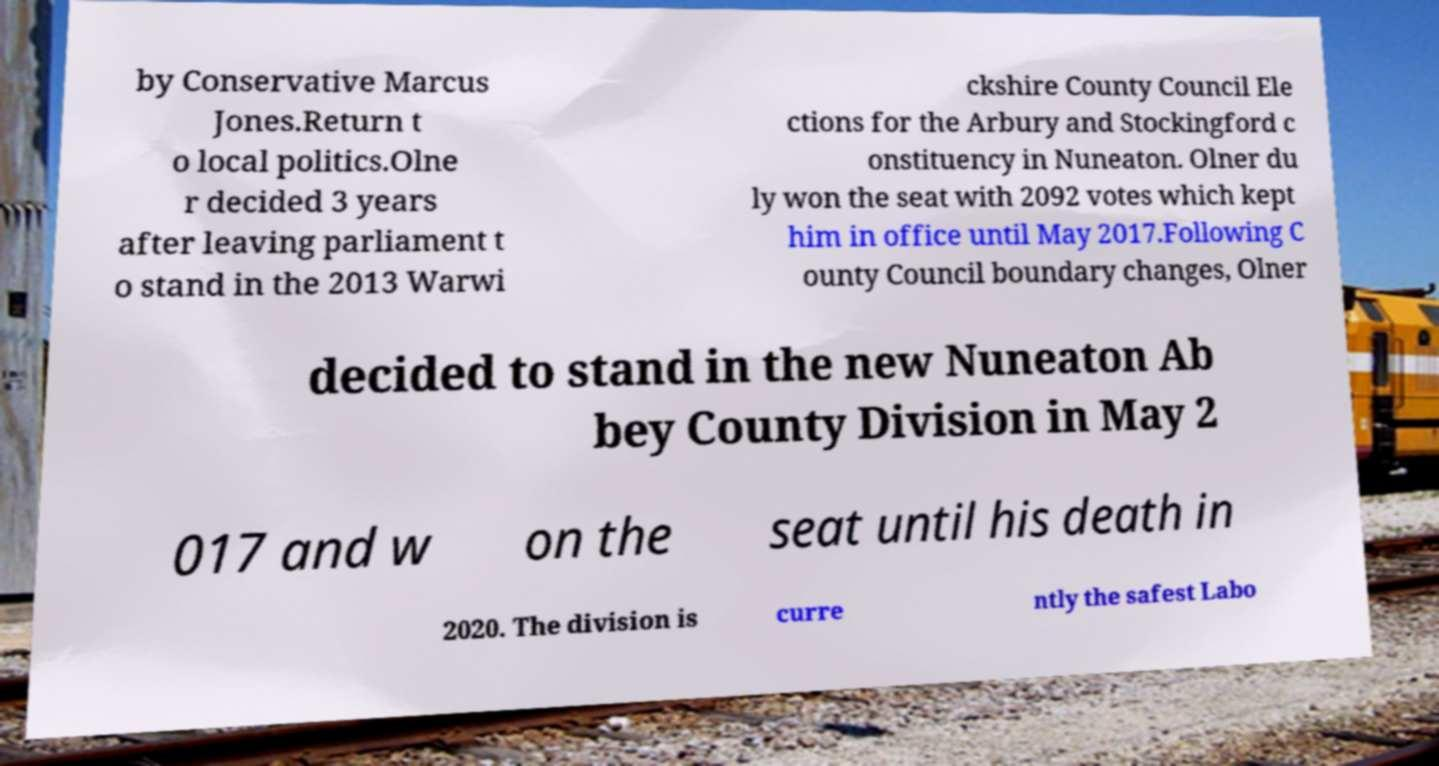Please identify and transcribe the text found in this image. by Conservative Marcus Jones.Return t o local politics.Olne r decided 3 years after leaving parliament t o stand in the 2013 Warwi ckshire County Council Ele ctions for the Arbury and Stockingford c onstituency in Nuneaton. Olner du ly won the seat with 2092 votes which kept him in office until May 2017.Following C ounty Council boundary changes, Olner decided to stand in the new Nuneaton Ab bey County Division in May 2 017 and w on the seat until his death in 2020. The division is curre ntly the safest Labo 